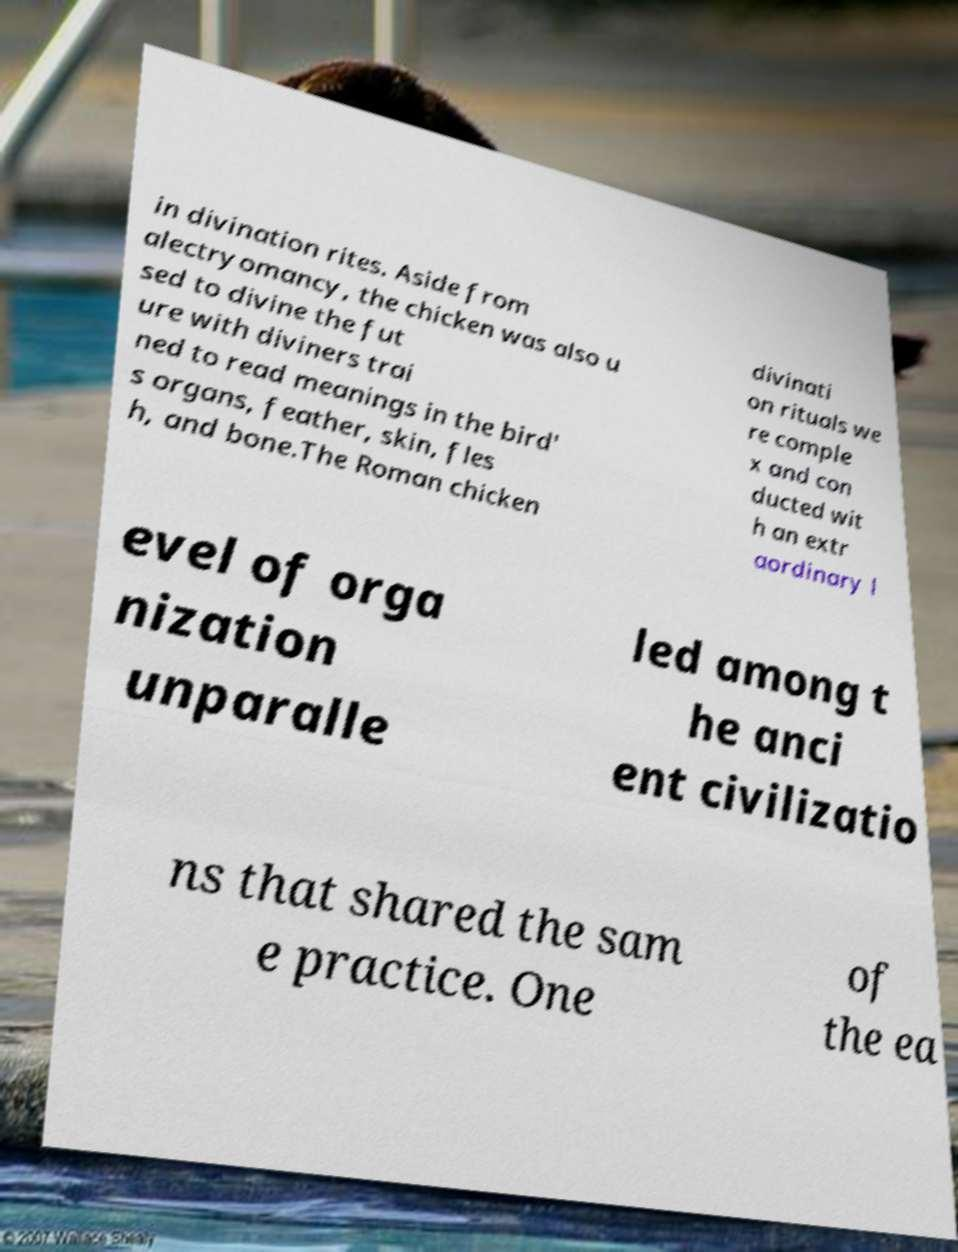Please identify and transcribe the text found in this image. in divination rites. Aside from alectryomancy, the chicken was also u sed to divine the fut ure with diviners trai ned to read meanings in the bird' s organs, feather, skin, fles h, and bone.The Roman chicken divinati on rituals we re comple x and con ducted wit h an extr aordinary l evel of orga nization unparalle led among t he anci ent civilizatio ns that shared the sam e practice. One of the ea 